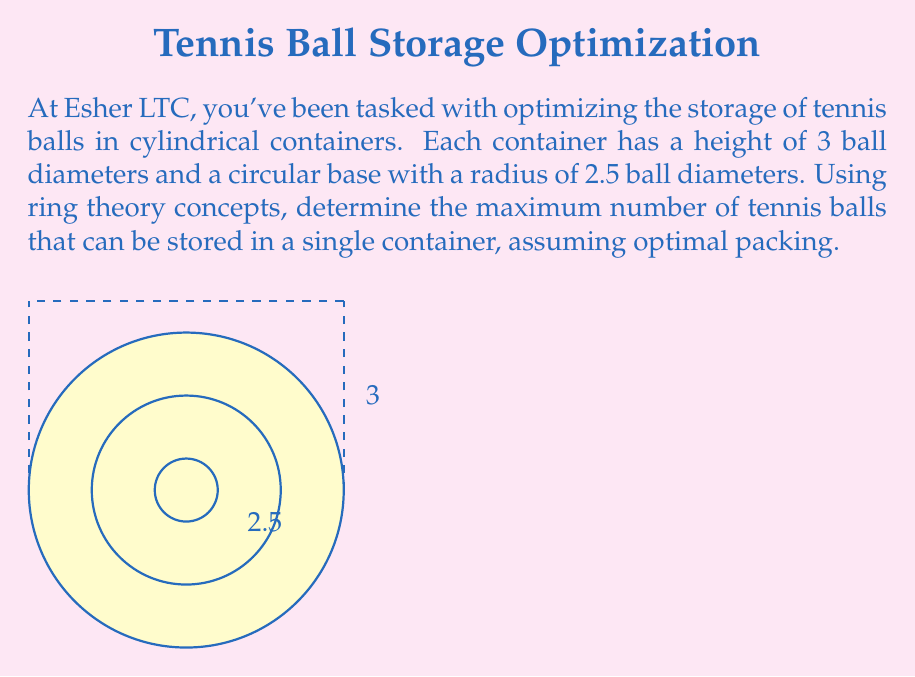Provide a solution to this math problem. Let's approach this problem step-by-step using concepts from ring theory:

1) First, we need to consider the arrangement of balls in each layer. The optimal packing for circles in a plane is a hexagonal lattice, which can be represented by the ring $\mathbb{Z}[\omega]$, where $\omega = e^{2\pi i/6}$.

2) In this lattice, each ball is surrounded by 6 others. The density of this packing is:

   $$\frac{\pi}{2\sqrt{3}} \approx 0.9069$$

3) Now, let's calculate the area of the base of our container:

   $$A = \pi r^2 = \pi (2.5)^2 = 6.25\pi$$

4) The number of balls in a single layer can be approximated by:

   $$N_{layer} = 6.25\pi \cdot \frac{\pi}{2\sqrt{3}} \approx 17.82$$

   Rounding down, we get 17 balls per layer.

5) The container can fit 3 layers of balls stacked vertically.

6) Therefore, the total number of balls is:

   $$N_{total} = 3 \cdot 17 = 51$$

7) However, we can potentially fit one more ball in the center of the top layer if there's space. To check this, we need to calculate if the radius of the container minus the radius of a ball is greater than $\sqrt{3}$ times the radius of a ball (the distance between centers in a hexagonal packing):

   $$2.5 - 1 > \sqrt{3}$$
   $$1.5 > 1.732$$

   This is false, so we cannot fit an extra ball in the center of the top layer.
Answer: 51 tennis balls 